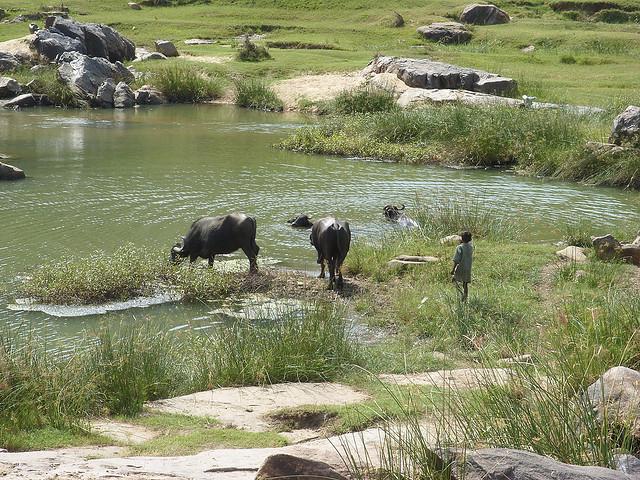How many animals are there?
Quick response, please. 2. What type of animal is in the water?
Concise answer only. Water buffalo. Is there a person in the photo?
Concise answer only. Yes. 